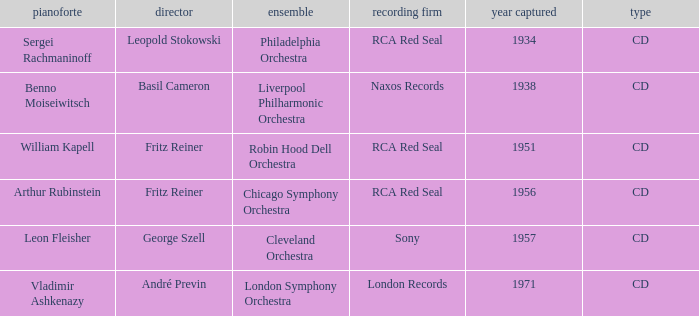Where is the orchestra when the year of recording is 1934? Philadelphia Orchestra. 